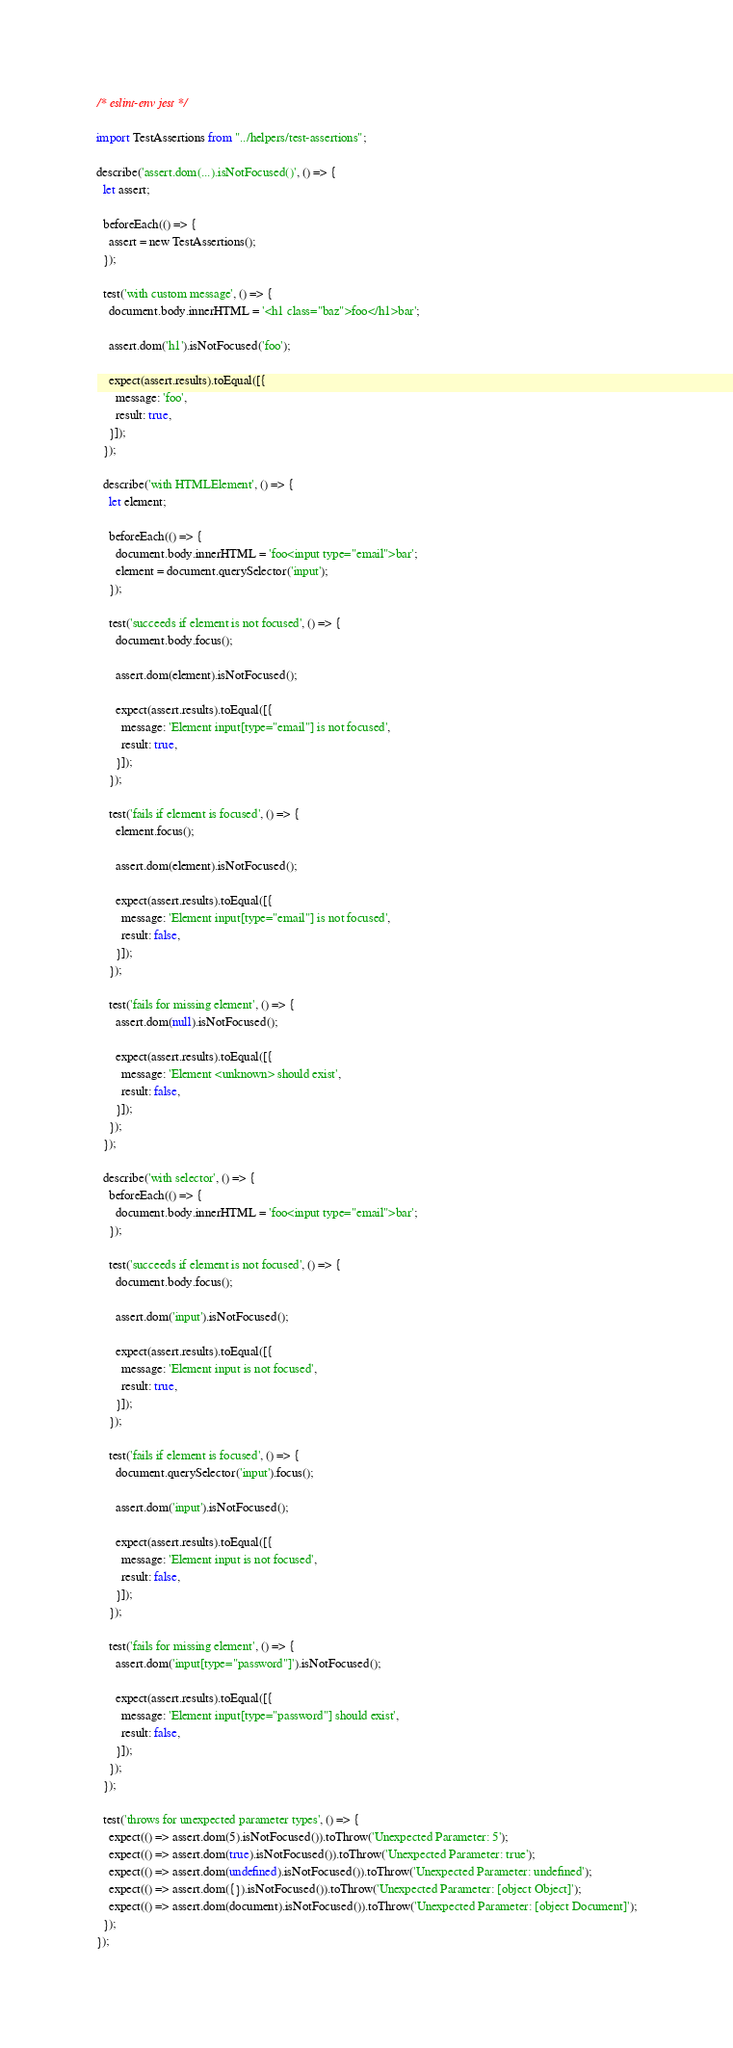<code> <loc_0><loc_0><loc_500><loc_500><_TypeScript_>/* eslint-env jest */

import TestAssertions from "../helpers/test-assertions";

describe('assert.dom(...).isNotFocused()', () => {
  let assert;

  beforeEach(() => {
    assert = new TestAssertions();
  });

  test('with custom message', () => {
    document.body.innerHTML = '<h1 class="baz">foo</h1>bar';

    assert.dom('h1').isNotFocused('foo');

    expect(assert.results).toEqual([{
      message: 'foo',
      result: true,
    }]);
  });

  describe('with HTMLElement', () => {
    let element;

    beforeEach(() => {
      document.body.innerHTML = 'foo<input type="email">bar';
      element = document.querySelector('input');
    });

    test('succeeds if element is not focused', () => {
      document.body.focus();

      assert.dom(element).isNotFocused();

      expect(assert.results).toEqual([{
        message: 'Element input[type="email"] is not focused',
        result: true,
      }]);
    });

    test('fails if element is focused', () => {
      element.focus();

      assert.dom(element).isNotFocused();

      expect(assert.results).toEqual([{
        message: 'Element input[type="email"] is not focused',
        result: false,
      }]);
    });

    test('fails for missing element', () => {
      assert.dom(null).isNotFocused();

      expect(assert.results).toEqual([{
        message: 'Element <unknown> should exist',
        result: false,
      }]);
    });
  });

  describe('with selector', () => {
    beforeEach(() => {
      document.body.innerHTML = 'foo<input type="email">bar';
    });

    test('succeeds if element is not focused', () => {
      document.body.focus();

      assert.dom('input').isNotFocused();

      expect(assert.results).toEqual([{
        message: 'Element input is not focused',
        result: true,
      }]);
    });

    test('fails if element is focused', () => {
      document.querySelector('input').focus();

      assert.dom('input').isNotFocused();

      expect(assert.results).toEqual([{
        message: 'Element input is not focused',
        result: false,
      }]);
    });

    test('fails for missing element', () => {
      assert.dom('input[type="password"]').isNotFocused();

      expect(assert.results).toEqual([{
        message: 'Element input[type="password"] should exist',
        result: false,
      }]);
    });
  });

  test('throws for unexpected parameter types', () => {
    expect(() => assert.dom(5).isNotFocused()).toThrow('Unexpected Parameter: 5');
    expect(() => assert.dom(true).isNotFocused()).toThrow('Unexpected Parameter: true');
    expect(() => assert.dom(undefined).isNotFocused()).toThrow('Unexpected Parameter: undefined');
    expect(() => assert.dom({}).isNotFocused()).toThrow('Unexpected Parameter: [object Object]');
    expect(() => assert.dom(document).isNotFocused()).toThrow('Unexpected Parameter: [object Document]');
  });
});
</code> 